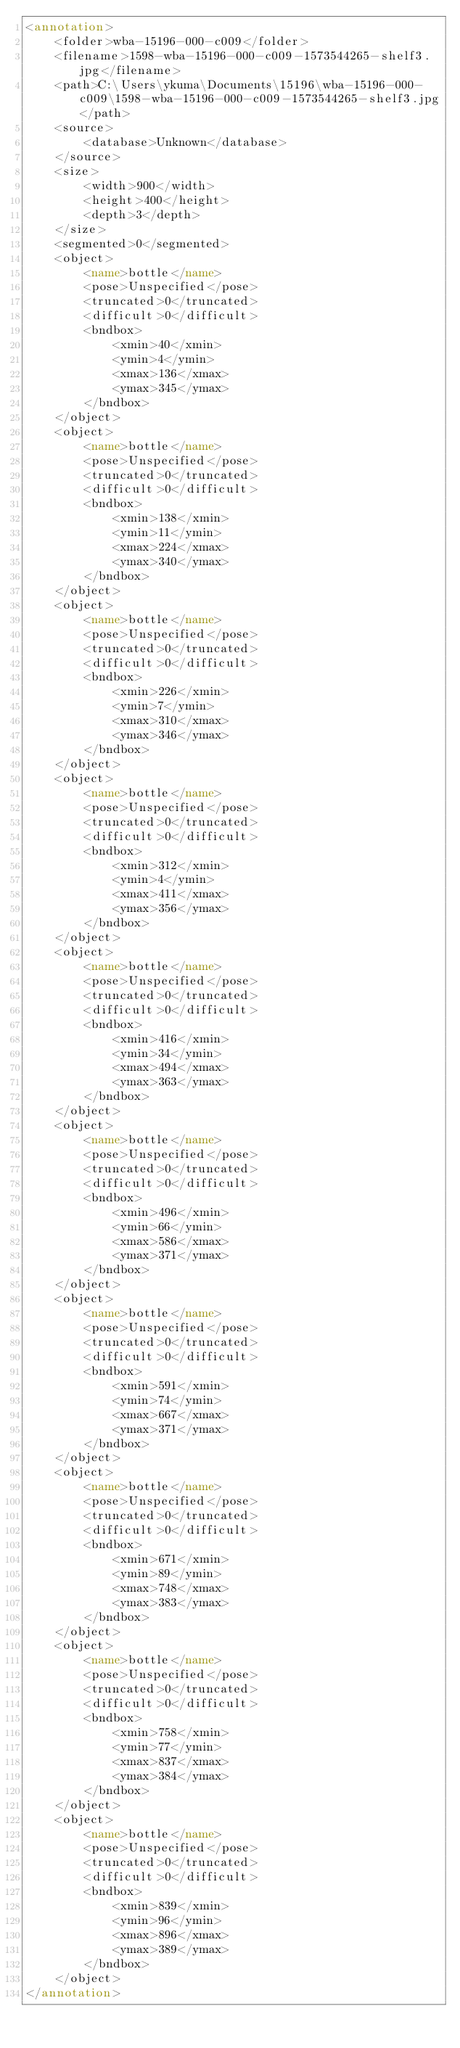<code> <loc_0><loc_0><loc_500><loc_500><_XML_><annotation>
	<folder>wba-15196-000-c009</folder>
	<filename>1598-wba-15196-000-c009-1573544265-shelf3.jpg</filename>
	<path>C:\Users\ykuma\Documents\15196\wba-15196-000-c009\1598-wba-15196-000-c009-1573544265-shelf3.jpg</path>
	<source>
		<database>Unknown</database>
	</source>
	<size>
		<width>900</width>
		<height>400</height>
		<depth>3</depth>
	</size>
	<segmented>0</segmented>
	<object>
		<name>bottle</name>
		<pose>Unspecified</pose>
		<truncated>0</truncated>
		<difficult>0</difficult>
		<bndbox>
			<xmin>40</xmin>
			<ymin>4</ymin>
			<xmax>136</xmax>
			<ymax>345</ymax>
		</bndbox>
	</object>
	<object>
		<name>bottle</name>
		<pose>Unspecified</pose>
		<truncated>0</truncated>
		<difficult>0</difficult>
		<bndbox>
			<xmin>138</xmin>
			<ymin>11</ymin>
			<xmax>224</xmax>
			<ymax>340</ymax>
		</bndbox>
	</object>
	<object>
		<name>bottle</name>
		<pose>Unspecified</pose>
		<truncated>0</truncated>
		<difficult>0</difficult>
		<bndbox>
			<xmin>226</xmin>
			<ymin>7</ymin>
			<xmax>310</xmax>
			<ymax>346</ymax>
		</bndbox>
	</object>
	<object>
		<name>bottle</name>
		<pose>Unspecified</pose>
		<truncated>0</truncated>
		<difficult>0</difficult>
		<bndbox>
			<xmin>312</xmin>
			<ymin>4</ymin>
			<xmax>411</xmax>
			<ymax>356</ymax>
		</bndbox>
	</object>
	<object>
		<name>bottle</name>
		<pose>Unspecified</pose>
		<truncated>0</truncated>
		<difficult>0</difficult>
		<bndbox>
			<xmin>416</xmin>
			<ymin>34</ymin>
			<xmax>494</xmax>
			<ymax>363</ymax>
		</bndbox>
	</object>
	<object>
		<name>bottle</name>
		<pose>Unspecified</pose>
		<truncated>0</truncated>
		<difficult>0</difficult>
		<bndbox>
			<xmin>496</xmin>
			<ymin>66</ymin>
			<xmax>586</xmax>
			<ymax>371</ymax>
		</bndbox>
	</object>
	<object>
		<name>bottle</name>
		<pose>Unspecified</pose>
		<truncated>0</truncated>
		<difficult>0</difficult>
		<bndbox>
			<xmin>591</xmin>
			<ymin>74</ymin>
			<xmax>667</xmax>
			<ymax>371</ymax>
		</bndbox>
	</object>
	<object>
		<name>bottle</name>
		<pose>Unspecified</pose>
		<truncated>0</truncated>
		<difficult>0</difficult>
		<bndbox>
			<xmin>671</xmin>
			<ymin>89</ymin>
			<xmax>748</xmax>
			<ymax>383</ymax>
		</bndbox>
	</object>
	<object>
		<name>bottle</name>
		<pose>Unspecified</pose>
		<truncated>0</truncated>
		<difficult>0</difficult>
		<bndbox>
			<xmin>758</xmin>
			<ymin>77</ymin>
			<xmax>837</xmax>
			<ymax>384</ymax>
		</bndbox>
	</object>
	<object>
		<name>bottle</name>
		<pose>Unspecified</pose>
		<truncated>0</truncated>
		<difficult>0</difficult>
		<bndbox>
			<xmin>839</xmin>
			<ymin>96</ymin>
			<xmax>896</xmax>
			<ymax>389</ymax>
		</bndbox>
	</object>
</annotation></code> 